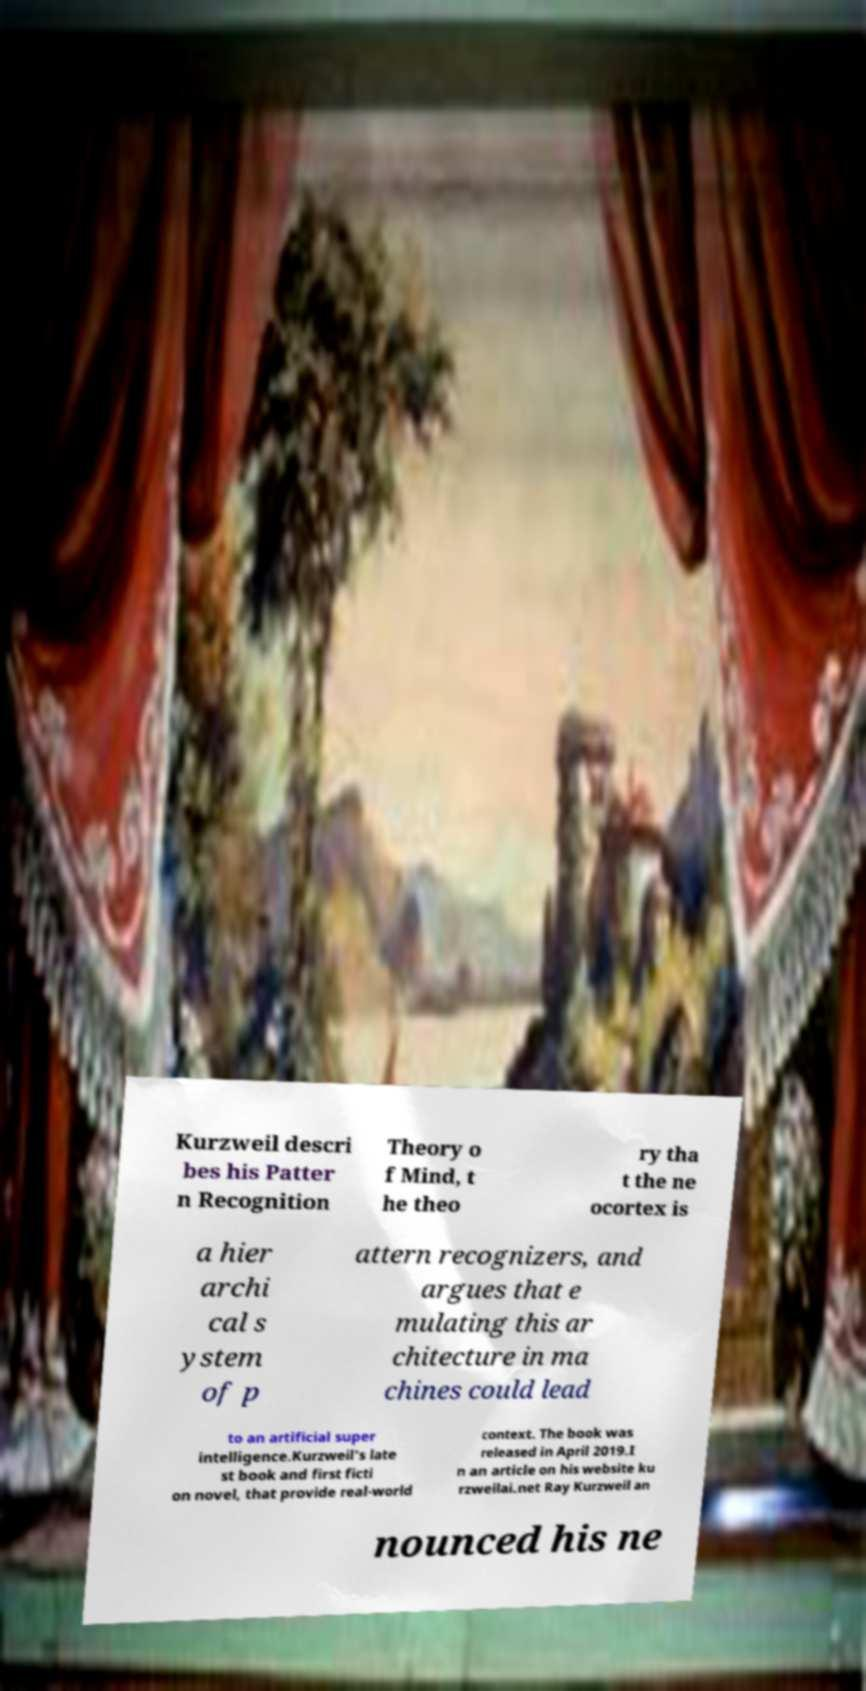Can you read and provide the text displayed in the image?This photo seems to have some interesting text. Can you extract and type it out for me? Kurzweil descri bes his Patter n Recognition Theory o f Mind, t he theo ry tha t the ne ocortex is a hier archi cal s ystem of p attern recognizers, and argues that e mulating this ar chitecture in ma chines could lead to an artificial super intelligence.Kurzweil's late st book and first ficti on novel, that provide real-world context. The book was released in April 2019.I n an article on his website ku rzweilai.net Ray Kurzweil an nounced his ne 